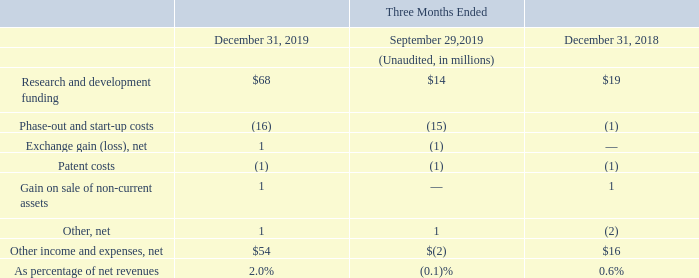In the fourth quarter of 2019, we recognized other income, net of expenses, of $54 million, increasing from a negative $2 million in the prior quarter and from an income of $16 million in the year-ago quarter, reflecting higher R&D grants in Italy associated with the IPCEI program.
Other income and expenses, net
Which program is associated to R&D? Ipcei program. How much was the Other income and expenses, net in the fourth quarter of 2019? $54 million. What led to increase in the other income and expenses, net in the fourth quarter of 2019? Higher r&d grants in italy associated with the ipcei program. What is the average Research and development funding for the period December 31, 2019 and 2018?
Answer scale should be: million. (68+19) / 2
Answer: 43.5. What is the average Other income and expenses, net for the period December 31, 2019 and 2018?
Answer scale should be: million. (54+16) /2
Answer: 35. What is the increase/ (decrease) in Research and development funding from the period December 31, 2018 to 2019?
Answer scale should be: million. 68-19
Answer: 49. 